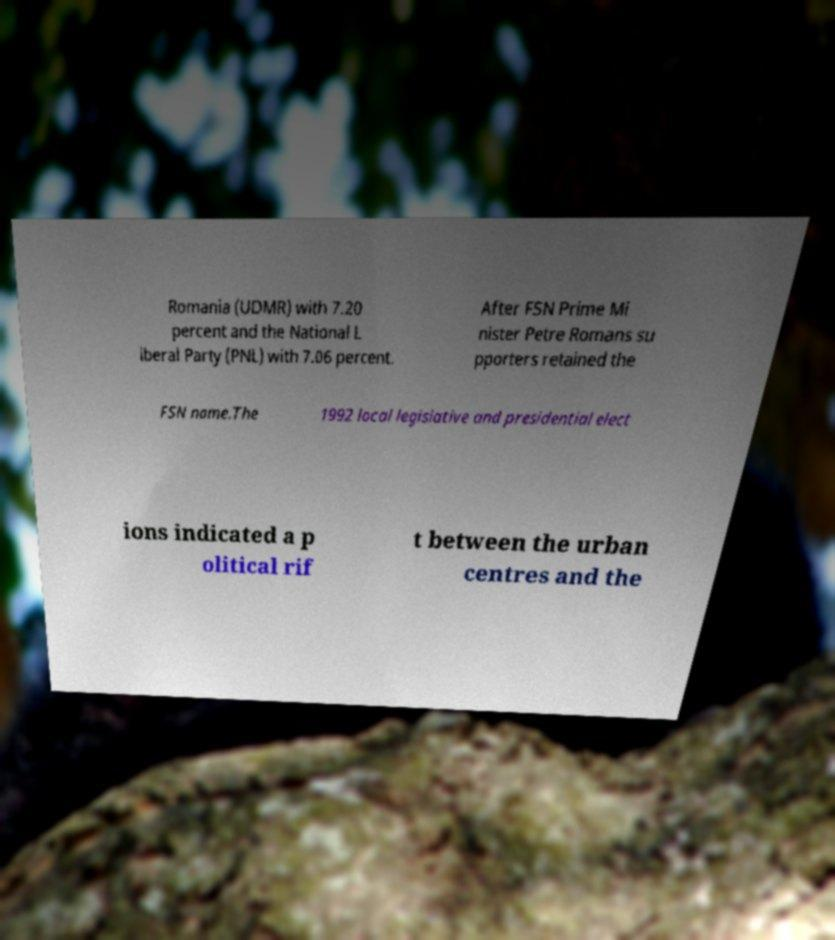Please identify and transcribe the text found in this image. Romania (UDMR) with 7.20 percent and the National L iberal Party (PNL) with 7.06 percent. After FSN Prime Mi nister Petre Romans su pporters retained the FSN name.The 1992 local legislative and presidential elect ions indicated a p olitical rif t between the urban centres and the 